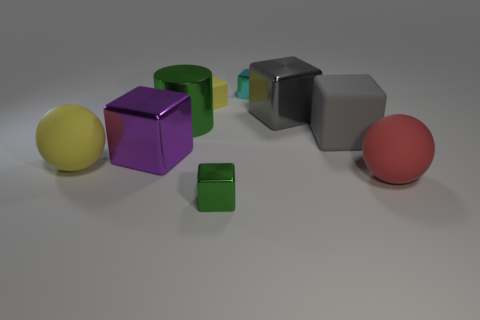What materials might these objects be made of, judging by their appearances? The objects in the image could be made of various materials. The ones with a reflective surface, such as the red and yellow spheres and the purple cube, might be made of a glossy plastic or painted wood. The matte grey cube, on the other hand, appears to have a more rubbery texture. 